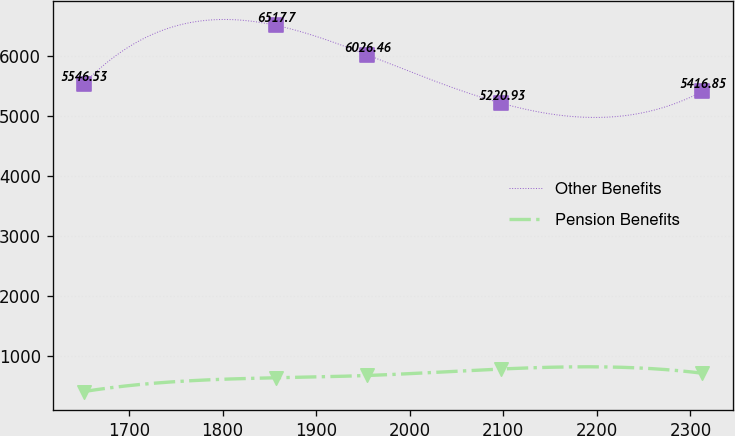Convert chart to OTSL. <chart><loc_0><loc_0><loc_500><loc_500><line_chart><ecel><fcel>Other Benefits<fcel>Pension Benefits<nl><fcel>1651.52<fcel>5546.53<fcel>414.13<nl><fcel>1856.79<fcel>6517.7<fcel>644.3<nl><fcel>1954.3<fcel>6026.46<fcel>681.9<nl><fcel>2097.61<fcel>5220.93<fcel>790.12<nl><fcel>2312.86<fcel>5416.85<fcel>719.5<nl></chart> 